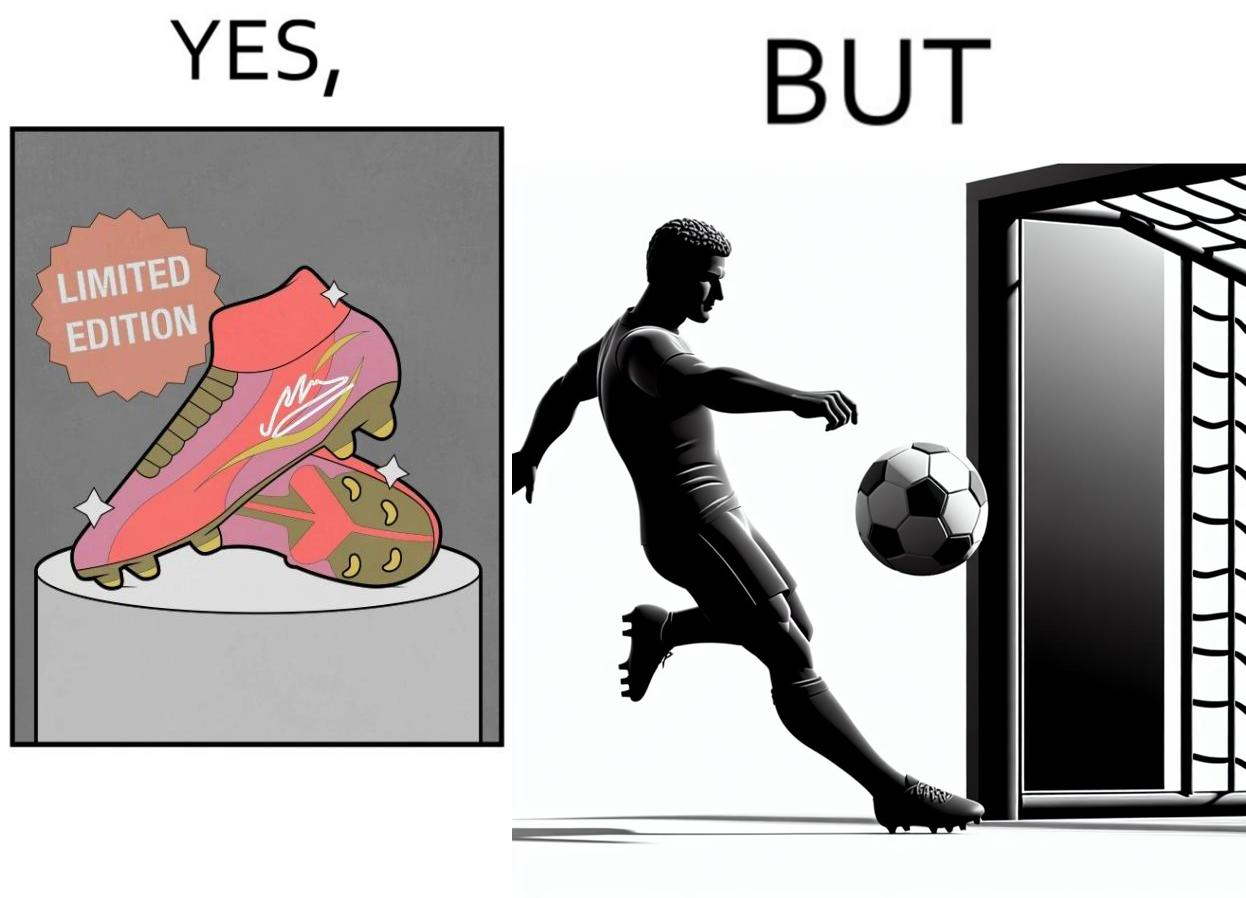What makes this image funny or satirical? The images are funny since they show how wearing expensive football boots does not make the user a better footballer. The footballer is still just as bad and it is a waste for him to buy such expensive boots 